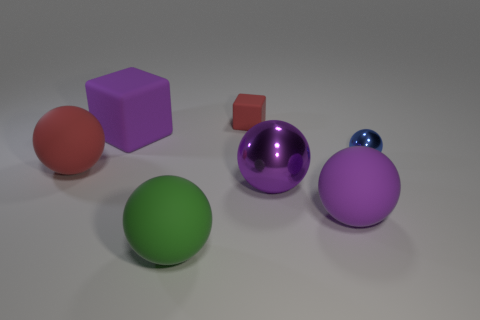Can you tell me the material that the purple object appears to be made of? The purple object has a shiny, reflective surface, which suggests it could be made of a polished metal or a smooth plastic with a metallic paint finish.  What might be the purpose of these various objects in the context where they are found? These objects, with their varied shapes and sizes, resemble items that might be found in a children's play area or used as part of a learning module for shape and color recognition. Each item can help distinguish size, form, and color in educational or recreational settings. 